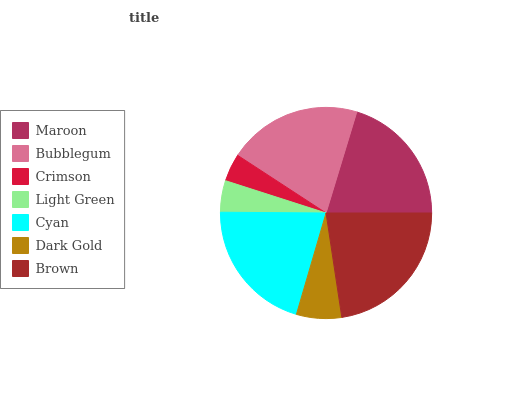Is Crimson the minimum?
Answer yes or no. Yes. Is Brown the maximum?
Answer yes or no. Yes. Is Bubblegum the minimum?
Answer yes or no. No. Is Bubblegum the maximum?
Answer yes or no. No. Is Bubblegum greater than Maroon?
Answer yes or no. Yes. Is Maroon less than Bubblegum?
Answer yes or no. Yes. Is Maroon greater than Bubblegum?
Answer yes or no. No. Is Bubblegum less than Maroon?
Answer yes or no. No. Is Maroon the high median?
Answer yes or no. Yes. Is Maroon the low median?
Answer yes or no. Yes. Is Brown the high median?
Answer yes or no. No. Is Bubblegum the low median?
Answer yes or no. No. 